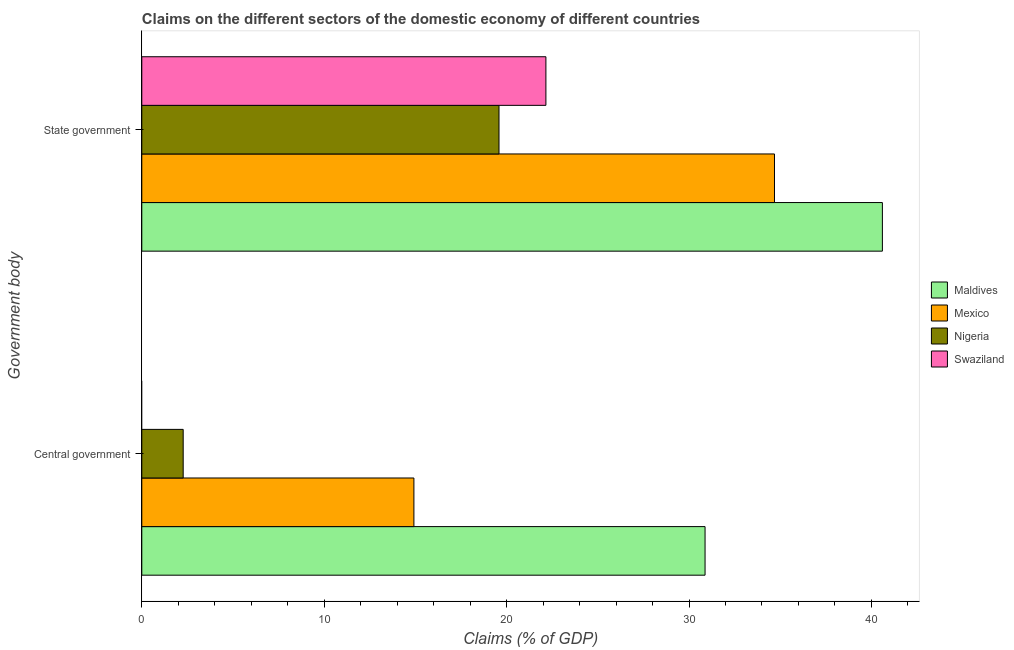How many different coloured bars are there?
Give a very brief answer. 4. Are the number of bars per tick equal to the number of legend labels?
Offer a terse response. No. Are the number of bars on each tick of the Y-axis equal?
Keep it short and to the point. No. How many bars are there on the 1st tick from the top?
Your answer should be very brief. 4. What is the label of the 1st group of bars from the top?
Offer a terse response. State government. What is the claims on central government in Mexico?
Ensure brevity in your answer.  14.92. Across all countries, what is the maximum claims on central government?
Your answer should be very brief. 30.88. Across all countries, what is the minimum claims on state government?
Your answer should be compact. 19.58. In which country was the claims on state government maximum?
Offer a terse response. Maldives. What is the total claims on central government in the graph?
Your answer should be very brief. 48.07. What is the difference between the claims on state government in Mexico and that in Nigeria?
Provide a succinct answer. 15.1. What is the difference between the claims on state government in Nigeria and the claims on central government in Swaziland?
Your response must be concise. 19.58. What is the average claims on central government per country?
Keep it short and to the point. 12.02. What is the difference between the claims on central government and claims on state government in Maldives?
Provide a short and direct response. -9.72. What is the ratio of the claims on central government in Maldives to that in Nigeria?
Offer a terse response. 13.61. Is the claims on state government in Nigeria less than that in Mexico?
Ensure brevity in your answer.  Yes. Are all the bars in the graph horizontal?
Provide a succinct answer. Yes. How many countries are there in the graph?
Offer a very short reply. 4. Does the graph contain grids?
Give a very brief answer. No. What is the title of the graph?
Give a very brief answer. Claims on the different sectors of the domestic economy of different countries. Does "Puerto Rico" appear as one of the legend labels in the graph?
Provide a short and direct response. No. What is the label or title of the X-axis?
Make the answer very short. Claims (% of GDP). What is the label or title of the Y-axis?
Keep it short and to the point. Government body. What is the Claims (% of GDP) of Maldives in Central government?
Your answer should be compact. 30.88. What is the Claims (% of GDP) in Mexico in Central government?
Provide a short and direct response. 14.92. What is the Claims (% of GDP) in Nigeria in Central government?
Offer a very short reply. 2.27. What is the Claims (% of GDP) of Swaziland in Central government?
Give a very brief answer. 0. What is the Claims (% of GDP) of Maldives in State government?
Ensure brevity in your answer.  40.6. What is the Claims (% of GDP) of Mexico in State government?
Provide a succinct answer. 34.69. What is the Claims (% of GDP) of Nigeria in State government?
Provide a succinct answer. 19.58. What is the Claims (% of GDP) of Swaziland in State government?
Provide a succinct answer. 22.15. Across all Government body, what is the maximum Claims (% of GDP) of Maldives?
Offer a terse response. 40.6. Across all Government body, what is the maximum Claims (% of GDP) in Mexico?
Offer a terse response. 34.69. Across all Government body, what is the maximum Claims (% of GDP) in Nigeria?
Ensure brevity in your answer.  19.58. Across all Government body, what is the maximum Claims (% of GDP) in Swaziland?
Your answer should be compact. 22.15. Across all Government body, what is the minimum Claims (% of GDP) of Maldives?
Keep it short and to the point. 30.88. Across all Government body, what is the minimum Claims (% of GDP) of Mexico?
Your answer should be compact. 14.92. Across all Government body, what is the minimum Claims (% of GDP) in Nigeria?
Your answer should be very brief. 2.27. What is the total Claims (% of GDP) in Maldives in the graph?
Give a very brief answer. 71.48. What is the total Claims (% of GDP) of Mexico in the graph?
Your answer should be very brief. 49.6. What is the total Claims (% of GDP) of Nigeria in the graph?
Your answer should be very brief. 21.85. What is the total Claims (% of GDP) in Swaziland in the graph?
Make the answer very short. 22.15. What is the difference between the Claims (% of GDP) in Maldives in Central government and that in State government?
Keep it short and to the point. -9.72. What is the difference between the Claims (% of GDP) of Mexico in Central government and that in State government?
Your answer should be compact. -19.77. What is the difference between the Claims (% of GDP) in Nigeria in Central government and that in State government?
Your answer should be very brief. -17.31. What is the difference between the Claims (% of GDP) in Maldives in Central government and the Claims (% of GDP) in Mexico in State government?
Make the answer very short. -3.81. What is the difference between the Claims (% of GDP) of Maldives in Central government and the Claims (% of GDP) of Nigeria in State government?
Make the answer very short. 11.3. What is the difference between the Claims (% of GDP) of Maldives in Central government and the Claims (% of GDP) of Swaziland in State government?
Keep it short and to the point. 8.73. What is the difference between the Claims (% of GDP) in Mexico in Central government and the Claims (% of GDP) in Nigeria in State government?
Your answer should be compact. -4.67. What is the difference between the Claims (% of GDP) of Mexico in Central government and the Claims (% of GDP) of Swaziland in State government?
Your response must be concise. -7.24. What is the difference between the Claims (% of GDP) in Nigeria in Central government and the Claims (% of GDP) in Swaziland in State government?
Your answer should be very brief. -19.89. What is the average Claims (% of GDP) of Maldives per Government body?
Your answer should be compact. 35.74. What is the average Claims (% of GDP) in Mexico per Government body?
Offer a very short reply. 24.8. What is the average Claims (% of GDP) of Nigeria per Government body?
Make the answer very short. 10.93. What is the average Claims (% of GDP) in Swaziland per Government body?
Make the answer very short. 11.08. What is the difference between the Claims (% of GDP) of Maldives and Claims (% of GDP) of Mexico in Central government?
Offer a terse response. 15.96. What is the difference between the Claims (% of GDP) in Maldives and Claims (% of GDP) in Nigeria in Central government?
Offer a very short reply. 28.61. What is the difference between the Claims (% of GDP) of Mexico and Claims (% of GDP) of Nigeria in Central government?
Offer a very short reply. 12.65. What is the difference between the Claims (% of GDP) in Maldives and Claims (% of GDP) in Mexico in State government?
Provide a short and direct response. 5.92. What is the difference between the Claims (% of GDP) in Maldives and Claims (% of GDP) in Nigeria in State government?
Offer a very short reply. 21.02. What is the difference between the Claims (% of GDP) of Maldives and Claims (% of GDP) of Swaziland in State government?
Provide a short and direct response. 18.45. What is the difference between the Claims (% of GDP) in Mexico and Claims (% of GDP) in Nigeria in State government?
Your answer should be very brief. 15.1. What is the difference between the Claims (% of GDP) of Mexico and Claims (% of GDP) of Swaziland in State government?
Ensure brevity in your answer.  12.53. What is the difference between the Claims (% of GDP) of Nigeria and Claims (% of GDP) of Swaziland in State government?
Give a very brief answer. -2.57. What is the ratio of the Claims (% of GDP) in Maldives in Central government to that in State government?
Keep it short and to the point. 0.76. What is the ratio of the Claims (% of GDP) of Mexico in Central government to that in State government?
Provide a short and direct response. 0.43. What is the ratio of the Claims (% of GDP) in Nigeria in Central government to that in State government?
Give a very brief answer. 0.12. What is the difference between the highest and the second highest Claims (% of GDP) of Maldives?
Offer a very short reply. 9.72. What is the difference between the highest and the second highest Claims (% of GDP) of Mexico?
Your answer should be very brief. 19.77. What is the difference between the highest and the second highest Claims (% of GDP) of Nigeria?
Your answer should be compact. 17.31. What is the difference between the highest and the lowest Claims (% of GDP) of Maldives?
Make the answer very short. 9.72. What is the difference between the highest and the lowest Claims (% of GDP) in Mexico?
Offer a very short reply. 19.77. What is the difference between the highest and the lowest Claims (% of GDP) in Nigeria?
Make the answer very short. 17.31. What is the difference between the highest and the lowest Claims (% of GDP) in Swaziland?
Your answer should be compact. 22.15. 